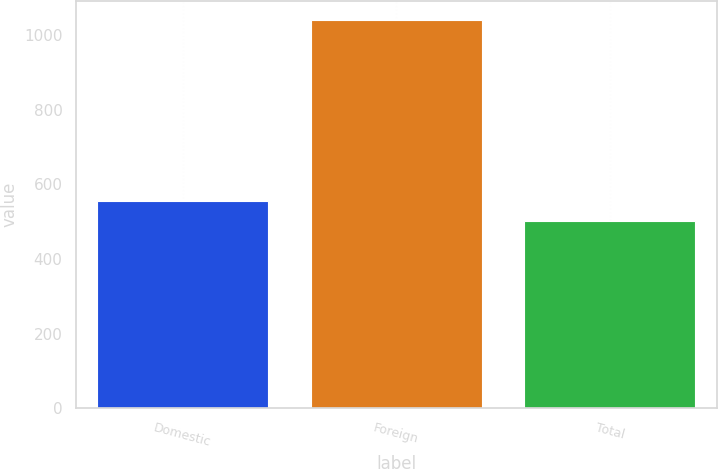Convert chart to OTSL. <chart><loc_0><loc_0><loc_500><loc_500><bar_chart><fcel>Domestic<fcel>Foreign<fcel>Total<nl><fcel>555.7<fcel>1039<fcel>502<nl></chart> 